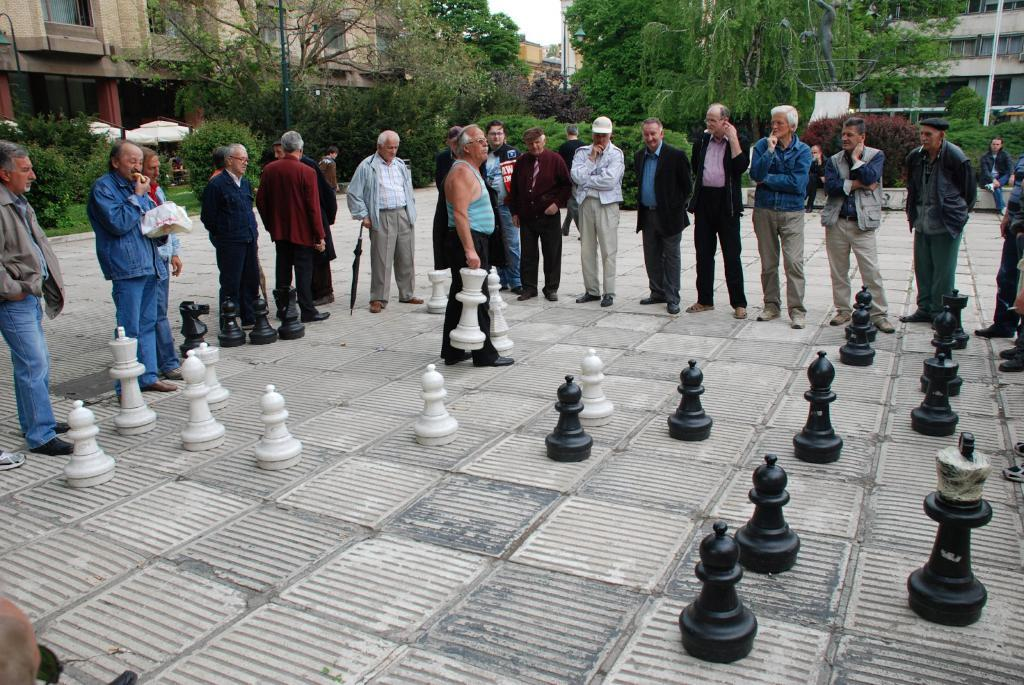What objects are at the bottom of the image? There are chess coins in the bottom of the image. What else can be seen in the image besides the chess coins? There are people standing in the image. What can be seen in the background of the image? There are trees and buildings in the background of the image. What type of paste is being used by the people in the image? There is no paste visible in the image; the people are standing without any apparent activity involving paste. 